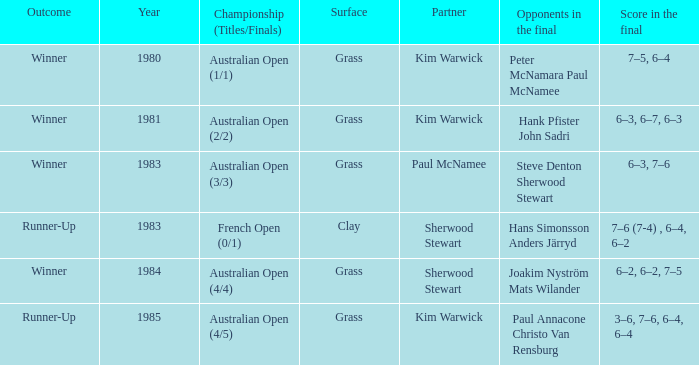Can you parse all the data within this table? {'header': ['Outcome', 'Year', 'Championship (Titles/Finals)', 'Surface', 'Partner', 'Opponents in the final', 'Score in the final'], 'rows': [['Winner', '1980', 'Australian Open (1/1)', 'Grass', 'Kim Warwick', 'Peter McNamara Paul McNamee', '7–5, 6–4'], ['Winner', '1981', 'Australian Open (2/2)', 'Grass', 'Kim Warwick', 'Hank Pfister John Sadri', '6–3, 6–7, 6–3'], ['Winner', '1983', 'Australian Open (3/3)', 'Grass', 'Paul McNamee', 'Steve Denton Sherwood Stewart', '6–3, 7–6'], ['Runner-Up', '1983', 'French Open (0/1)', 'Clay', 'Sherwood Stewart', 'Hans Simonsson Anders Järryd', '7–6 (7-4) , 6–4, 6–2'], ['Winner', '1984', 'Australian Open (4/4)', 'Grass', 'Sherwood Stewart', 'Joakim Nyström Mats Wilander', '6–2, 6–2, 7–5'], ['Runner-Up', '1985', 'Australian Open (4/5)', 'Grass', 'Kim Warwick', 'Paul Annacone Christo Van Rensburg', '3–6, 7–6, 6–4, 6–4']]} In 1981, what championship occurred? Australian Open (2/2). 